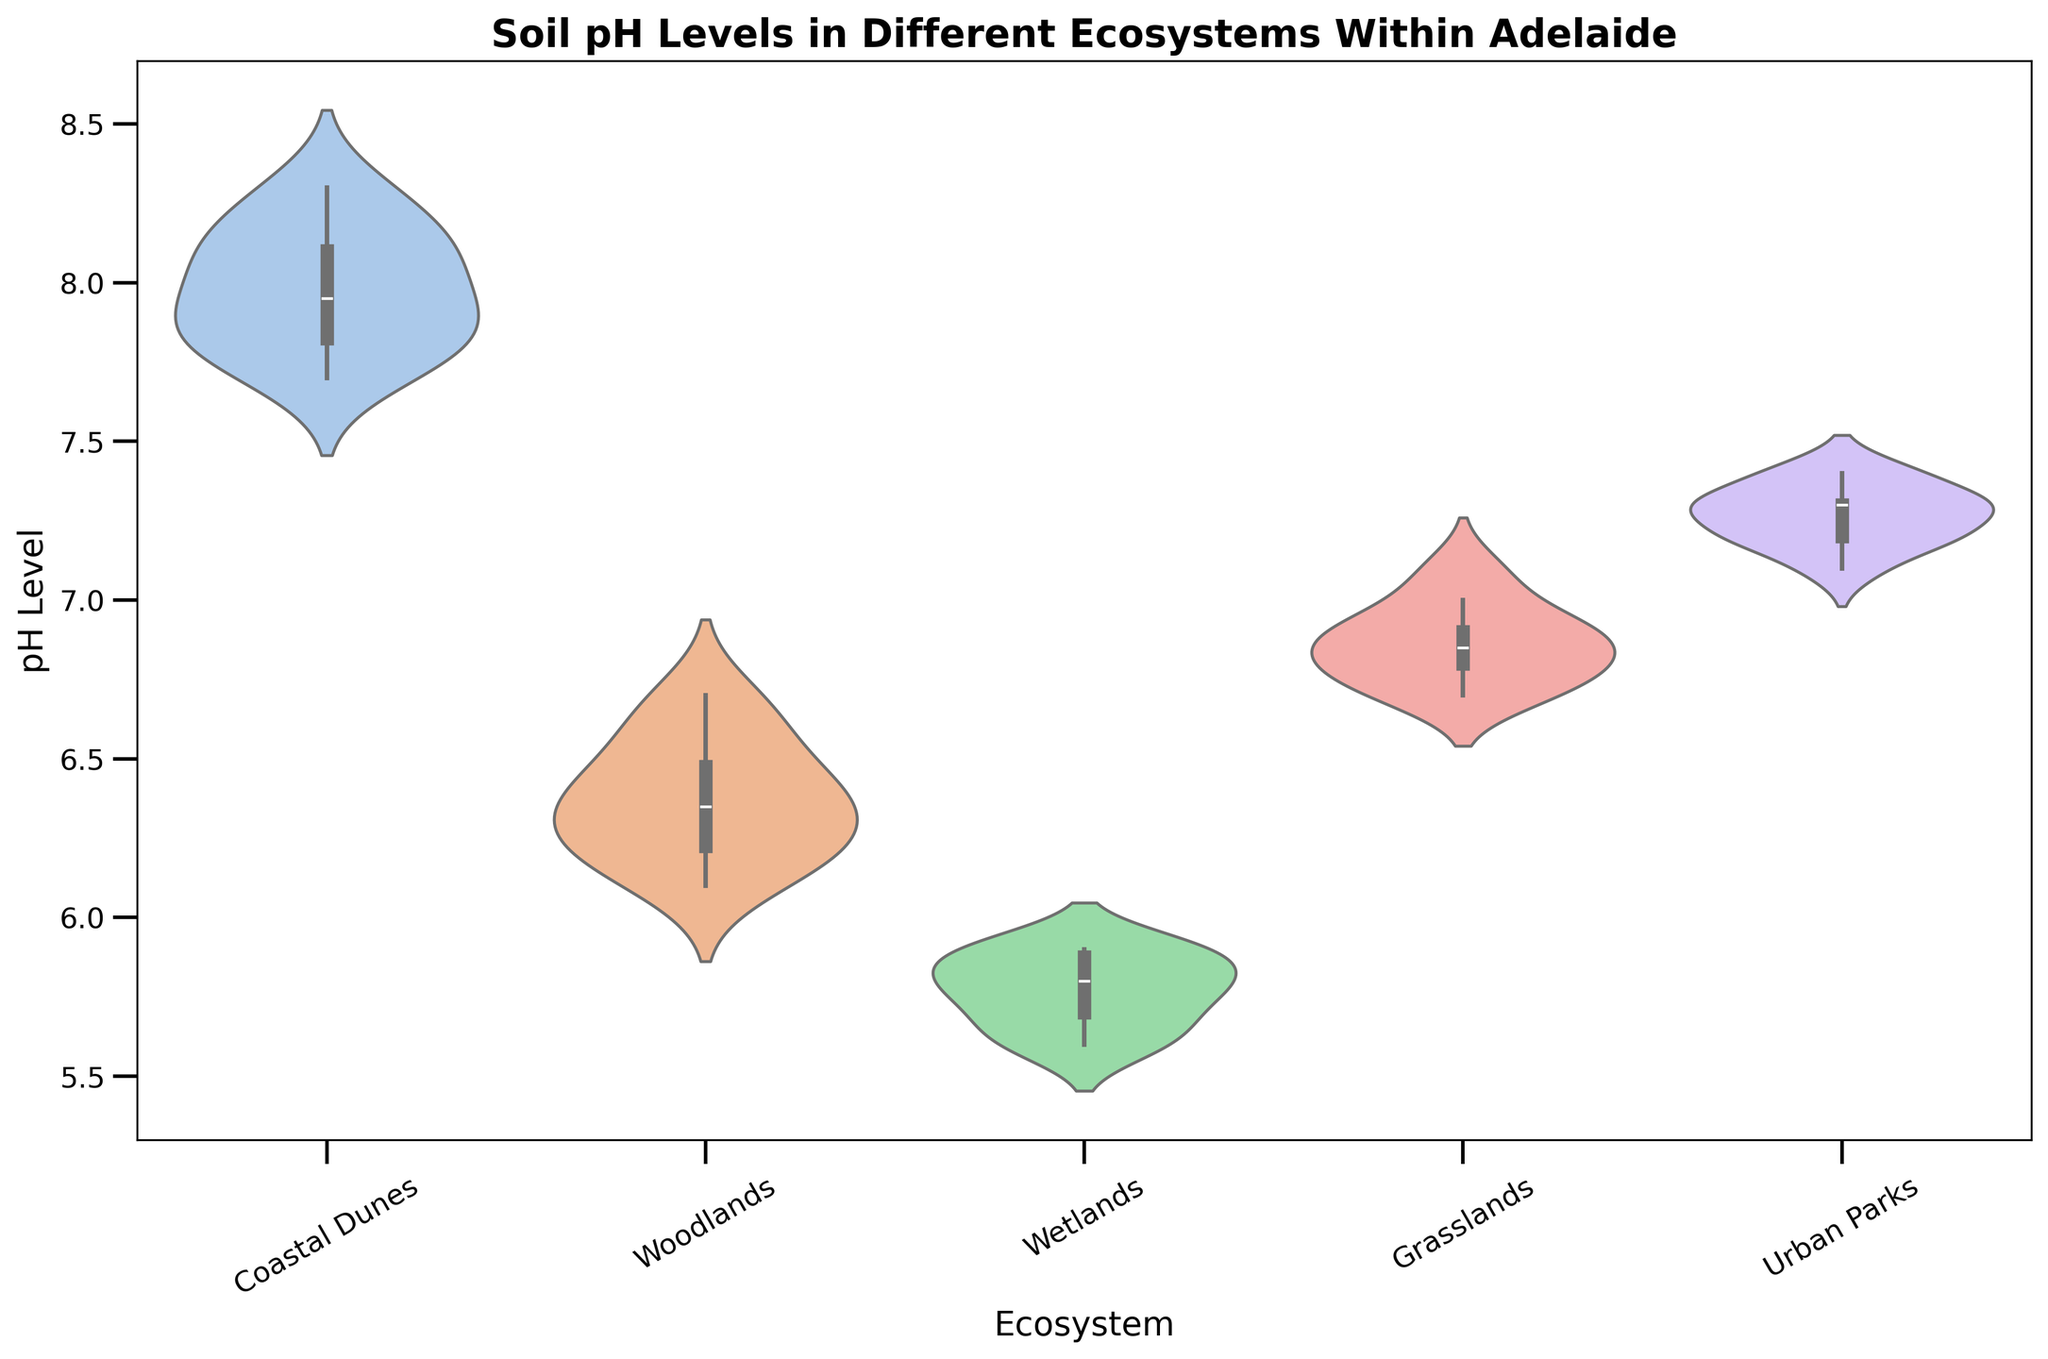Which ecosystem has the highest median soil pH level? To find the highest median soil pH level, look for the ecosystem with the thickest part of the violin plot (middle line) positioned the highest on the y-axis.
Answer: Coastal Dunes Which ecosystem shows the most variability in soil pH levels? Variability is indicated by the spread (width and height) of the violin plot. Look for the violin plot that is the widest and/or tallest.
Answer: Coastal Dunes What is the median pH level for Woodlands? The median is the middle value where the thickest part of the violin plot is located. Check the position of this thickest part on the y-axis for Woodlands.
Answer: 6.4 Between Wetlands and Grasslands, which has a higher maximum pH level? Look at the topmost point of the violin plots for Wetlands and Grasslands and compare their positions on the y-axis.
Answer: Grasslands What is the interquartile range (IQR) of soil pH levels in Urban Parks? The IQR is the range between the first (25th percentile) and third quartiles (75th percentile). Observe the range within the violin plot's most dense area.
Answer: 7.1 to 7.3 Which ecosystem has the lowest minimum pH level? Identify the lowest points of the violin plots for each ecosystem and see which one is positioned the lowest on the y-axis.
Answer: Wetlands How does the median pH level of Urban Parks compare to Coastal Dunes? Compare the positions of the thickest central parts of the violin plots for Urban Parks and Coastal Dunes.
Answer: Urban Parks has a lower median pH level than Coastal Dunes Describe the distribution of pH levels in the Grasslands ecosystem. Observe the shape and spread of the Grasslands violin plot, noting the density and spread from minimum to maximum values.
Answer: Approximately symmetric, with a slight concentration around 6.8 to 6.9 Which ecosystem has the narrowest range of soil pH levels? Range is indicated by the total height of the violin plot. Find the plot with the smallest vertical spread.
Answer: Wetlands Between Woodlands and Urban Parks, which has a more symmetric distribution of soil pH levels? Symmetry is observed in the balanced shape of the violin plot. Compare the shapes of the Woodlands and Urban Parks plots for balance.
Answer: Urban Parks 